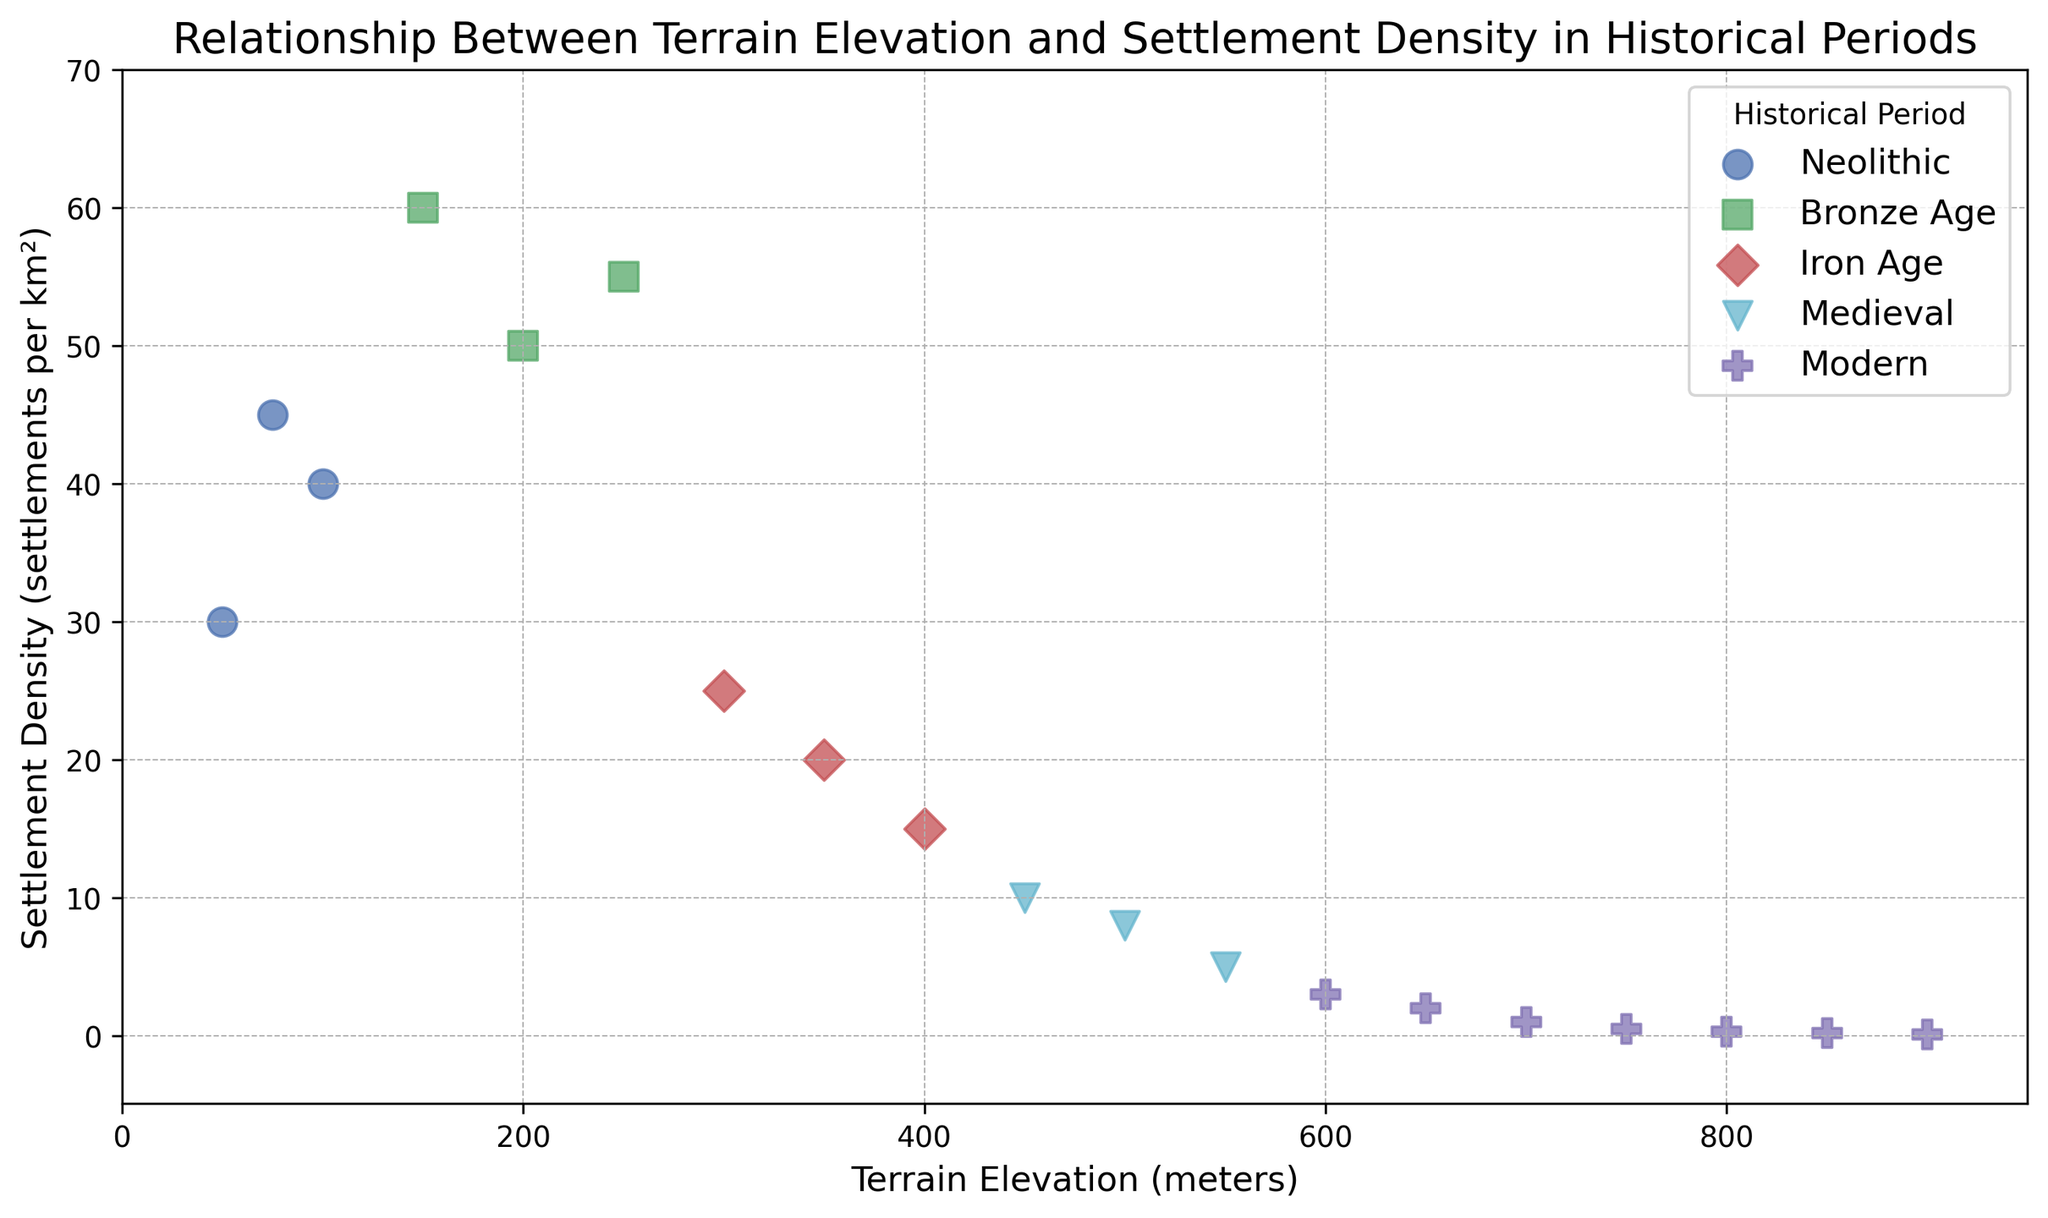What is the settlement density in the Bronze Age at 250 meters of elevation? The scatter plot shows data points for different historical periods with distinct markers/colors for each period. Locate the green square marker (representing Bronze Age) at the 250 meters elevation on the x-axis, and trace up to find the corresponding settlement density.
Answer: 55 Which historical period has the highest settlement density at any given elevation, and what is that density? Look for the highest data point on the y-axis and identify its corresponding marker and color. The highest data point is found at an elevation of 150 meters with a settlement density of 60, represented by a green square which indicates the Bronze Age.
Answer: Bronze Age, 60 What is the general trend in settlement density as elevation increases across all historical periods? Observe the overall pattern of the scatter points as elevation increases from left to right on the x-axis. There is a general decline in settlement density with increasing elevation.
Answer: Declining trend Compare the settlement densities between the Bronze Age and Modern period at 200 meters of elevation. Identify the markers/colors for Bronze Age (green square) and Modern (magenta pentagon) at 200 meters elevation. The settlement density for Bronze Age at 200 meters is 50, and for Modern, it is not directly present since the highest point for Modern starts at 600 meters. There's no Modern data point at 200 meters.
Answer: Bronze Age: 50, Modern: Not available What is the difference in settlement density between the highest and lowest elevation points in the Medieval period? Locate the Medieval markers (cyan triangles) at the highest and lowest elevations (450 meters and 550 meters). These points have settlement densities of 10 and 5, respectively. The difference is calculated as 10 - 5.
Answer: 5 On which elevation range does the Iron Age settlement density fall entirely below 30? Look for the red diamond markers representing Iron Age and note the elevation values for which the settlement density is below 30. Iron Age points fall in elevations from 300 to 400 meters, and all settlement densities for this period are below 30.
Answer: 300 to 400 meters How does the settlement density in the Neolithic period change between 50 meters and 100 meters of elevation? Examine the blue circle markers representing Neolithic at 50 meters, 75 meters, and 100 meters of elevation. The settlement densities are 30, 45, and 40, respectively. Initially, the density increases from 30 to 45, then it decreases to 40.
Answer: Increase then decrease What is the average settlement density for the Modern period? Calculate the mean of the settlement densities of the Modern period (magenta pentagon markers). The densities are 3, 2, 1, 0.5, 0.3, 0.2, 0.1. Sum them up: 3 + 2 + 1 + 0.5 + 0.3 + 0.2 + 0.1 = 7.1. Divide by the number of data points (7): 7.1 / 7.
Answer: 1.014 